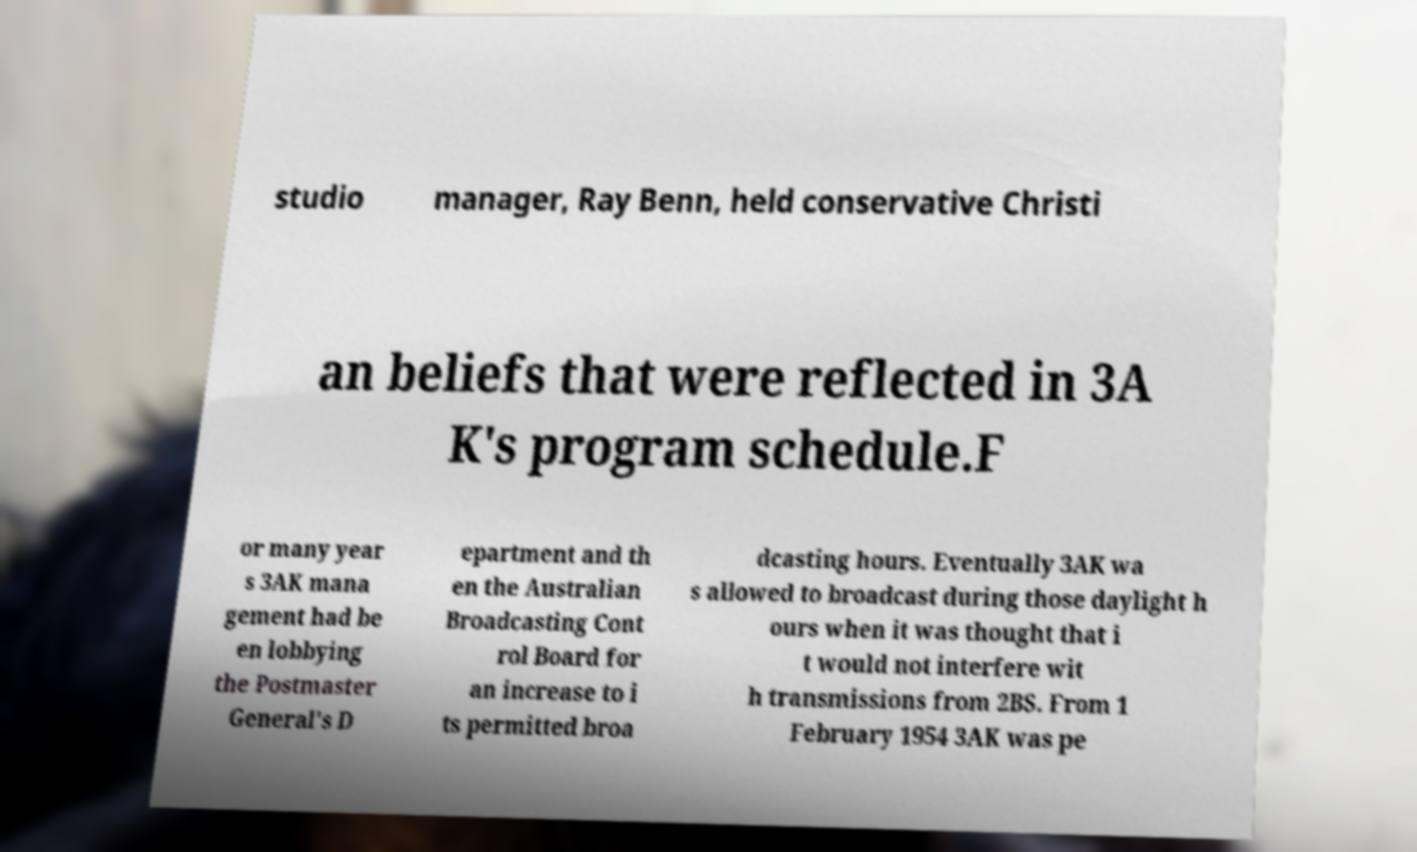Could you extract and type out the text from this image? studio manager, Ray Benn, held conservative Christi an beliefs that were reflected in 3A K's program schedule.F or many year s 3AK mana gement had be en lobbying the Postmaster General's D epartment and th en the Australian Broadcasting Cont rol Board for an increase to i ts permitted broa dcasting hours. Eventually 3AK wa s allowed to broadcast during those daylight h ours when it was thought that i t would not interfere wit h transmissions from 2BS. From 1 February 1954 3AK was pe 